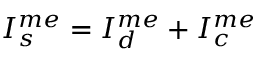<formula> <loc_0><loc_0><loc_500><loc_500>I _ { s } ^ { m e } = I _ { d } ^ { m e } + I _ { c } ^ { m e }</formula> 